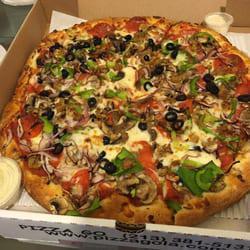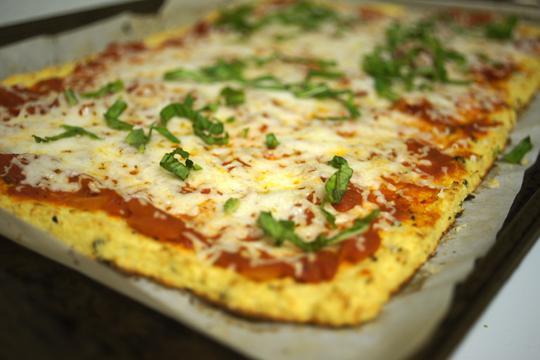The first image is the image on the left, the second image is the image on the right. For the images shown, is this caption "Both of the pizzas contain green parts." true? Answer yes or no. Yes. The first image is the image on the left, the second image is the image on the right. Analyze the images presented: Is the assertion "Each image features a round pizza shape, and at least one image shows a pizza in a round metal dish." valid? Answer yes or no. No. 